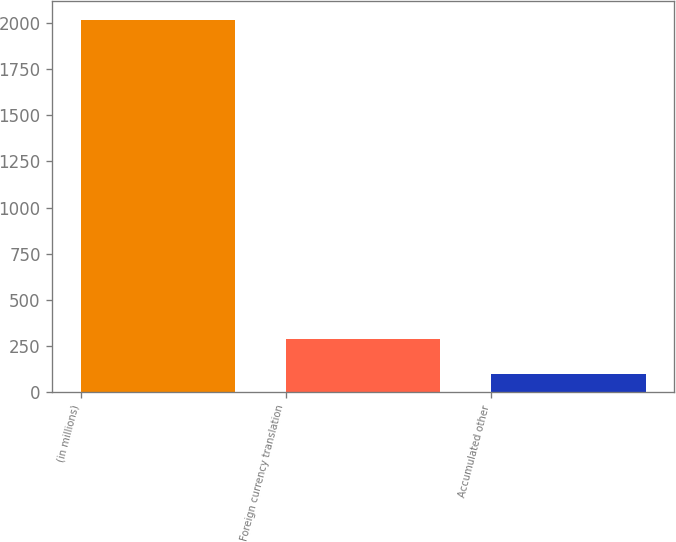<chart> <loc_0><loc_0><loc_500><loc_500><bar_chart><fcel>(in millions)<fcel>Foreign currency translation<fcel>Accumulated other<nl><fcel>2017<fcel>288.01<fcel>95.9<nl></chart> 